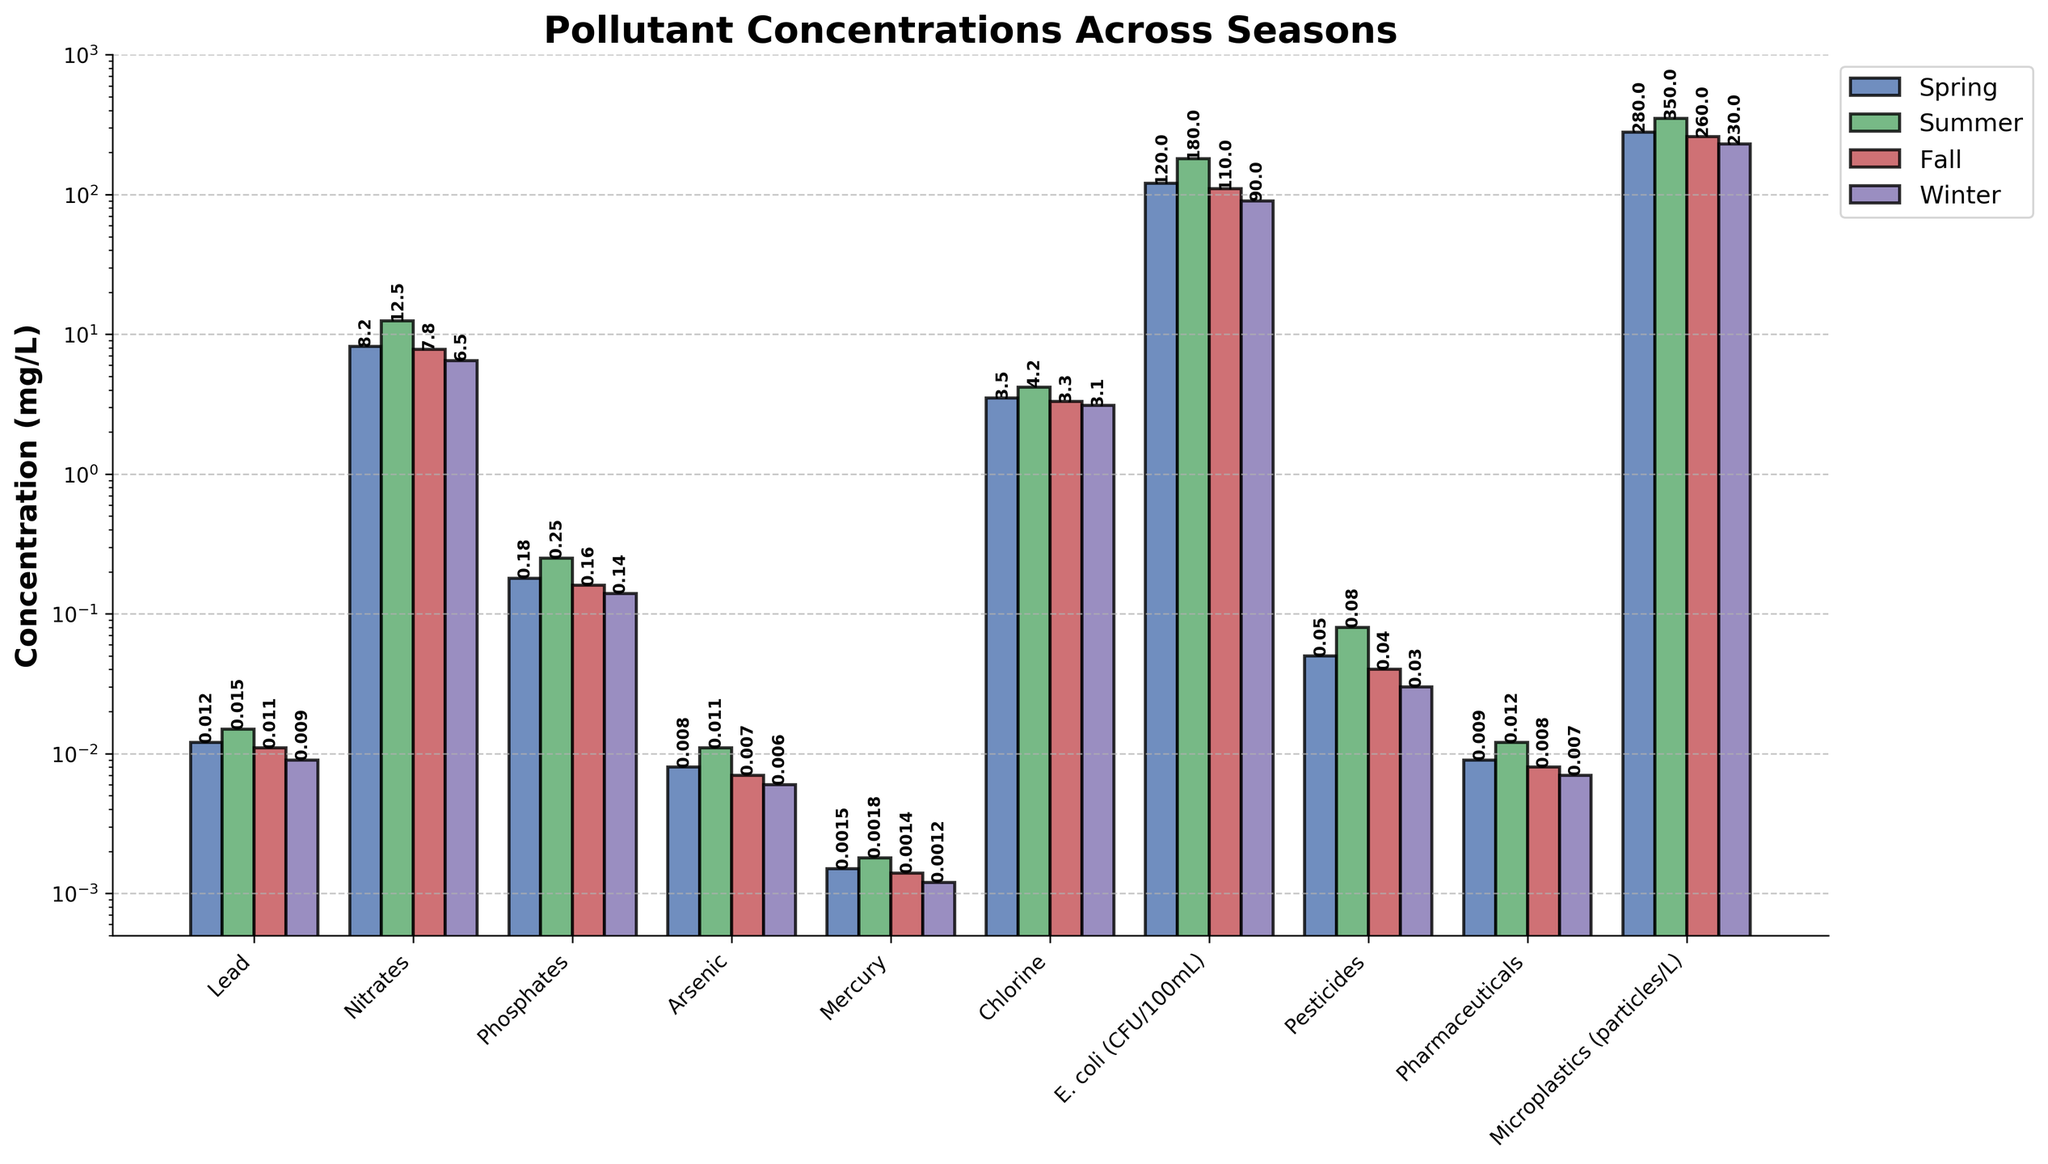Which pollutant has the highest concentration in summer? The highest bar in summer belongs to Nitrates with a concentration of 12.5 mg/L.
Answer: Nitrates Which season has the lowest concentration of Mercury? The lowest bar for Mercury in all seasons is for Winter with a concentration of 0.0012 mg/L.
Answer: Winter What's the difference in Lead concentration between Summer and Winter? The bars for Lead in Summer and Winter show concentrations of 0.015 mg/L and 0.009 mg/L, respectively. The difference is 0.015 - 0.009 = 0.006 mg/L.
Answer: 0.006 mg/L How do the concentrations of Pharmaceuticals in Fall and Spring compare? The bar for Pharmaceuticals in Fall is 0.008 mg/L, whereas in Spring it is 0.009 mg/L. Fall has a slightly lower concentration than Spring.
Answer: Fall has a lower concentration What's the average concentration of Phosphates across all seasons? The concentrations of Phosphates are 0.18 mg/L in Spring, 0.25 mg/L in Summer, 0.16 mg/L in Fall, and 0.14 mg/L in Winter. The average is (0.18 + 0.25 + 0.16 + 0.14) / 4 = 0.1825 mg/L.
Answer: 0.1825 mg/L Which season generally has the highest concentrations of all pollutants? Observing the visual heights and values of the bars, Summer generally has the highest concentrations for most pollutants, including Nitrates, Lead, and E. coli.
Answer: Summer What is the sum of Arsenic concentrations in Spring and Fall? The Arsenic concentrations are 0.008 mg/L in Spring and 0.007 mg/L in Fall. The sum is 0.008 + 0.007 = 0.015 mg/L.
Answer: 0.015 mg/L Is the concentration of Chlorine higher in Spring or Winter? The bars indicate that Chlorine's concentration is higher in Spring (3.5 mg/L) compared to Winter (3.1 mg/L).
Answer: Spring What's the ratio of E. coli concentrations in Summer to Winter? The E. coli concentrations are 180 CFU/100mL in Summer and 90 CFU/100mL in Winter. The ratio is 180 / 90 = 2.
Answer: 2 What is the combined concentration of all pollutants in Winter? Adding the Winter concentrations for each: Lead (0.009), Nitrates (6.5), Phosphates (0.14), Arsenic (0.006), Mercury (0.0012), Chlorine (3.1), E. coli (90), Pesticides (0.03), Pharmaceuticals (0.007), and Microplastics (230). The total is: 0.009 + 6.5 + 0.14 + 0.006 + 0.0012 + 3.1 + 90 + 0.03 + 0.007 + 230 = 329.7932.
Answer: 329.7932 